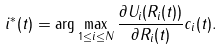<formula> <loc_0><loc_0><loc_500><loc_500>i ^ { * } ( t ) = \arg \max _ { 1 \leq i \leq N } { \frac { \partial U _ { i } ( R _ { i } ( t ) ) } { \partial R _ { i } ( t ) } c _ { i } ( t ) } .</formula> 